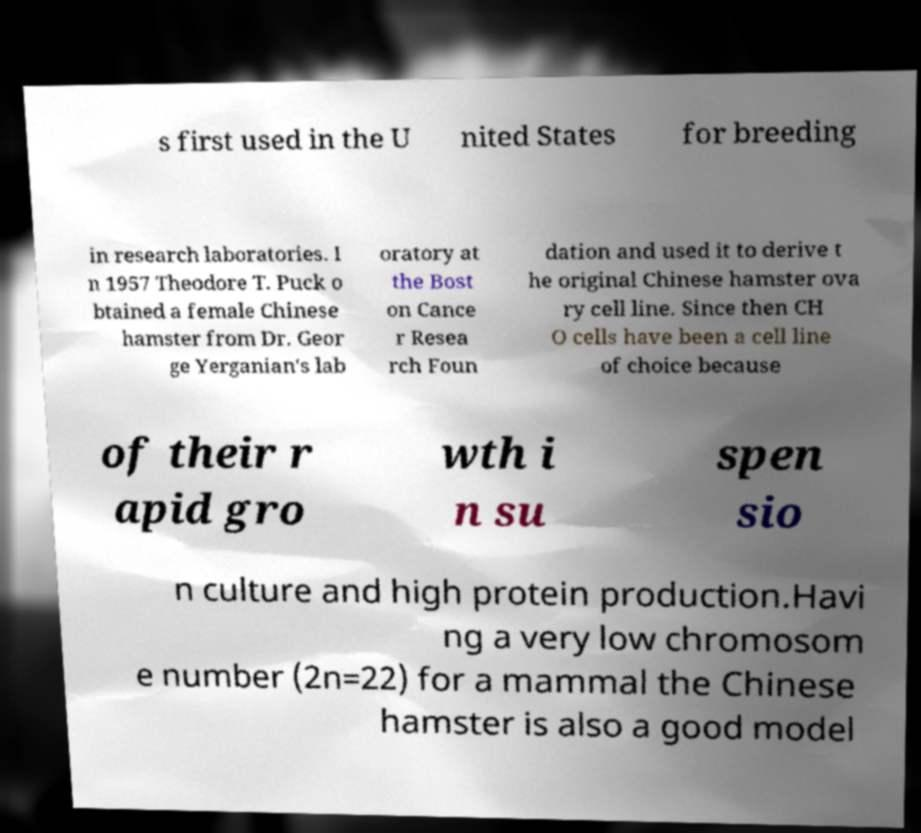What messages or text are displayed in this image? I need them in a readable, typed format. s first used in the U nited States for breeding in research laboratories. I n 1957 Theodore T. Puck o btained a female Chinese hamster from Dr. Geor ge Yerganian's lab oratory at the Bost on Cance r Resea rch Foun dation and used it to derive t he original Chinese hamster ova ry cell line. Since then CH O cells have been a cell line of choice because of their r apid gro wth i n su spen sio n culture and high protein production.Havi ng a very low chromosom e number (2n=22) for a mammal the Chinese hamster is also a good model 